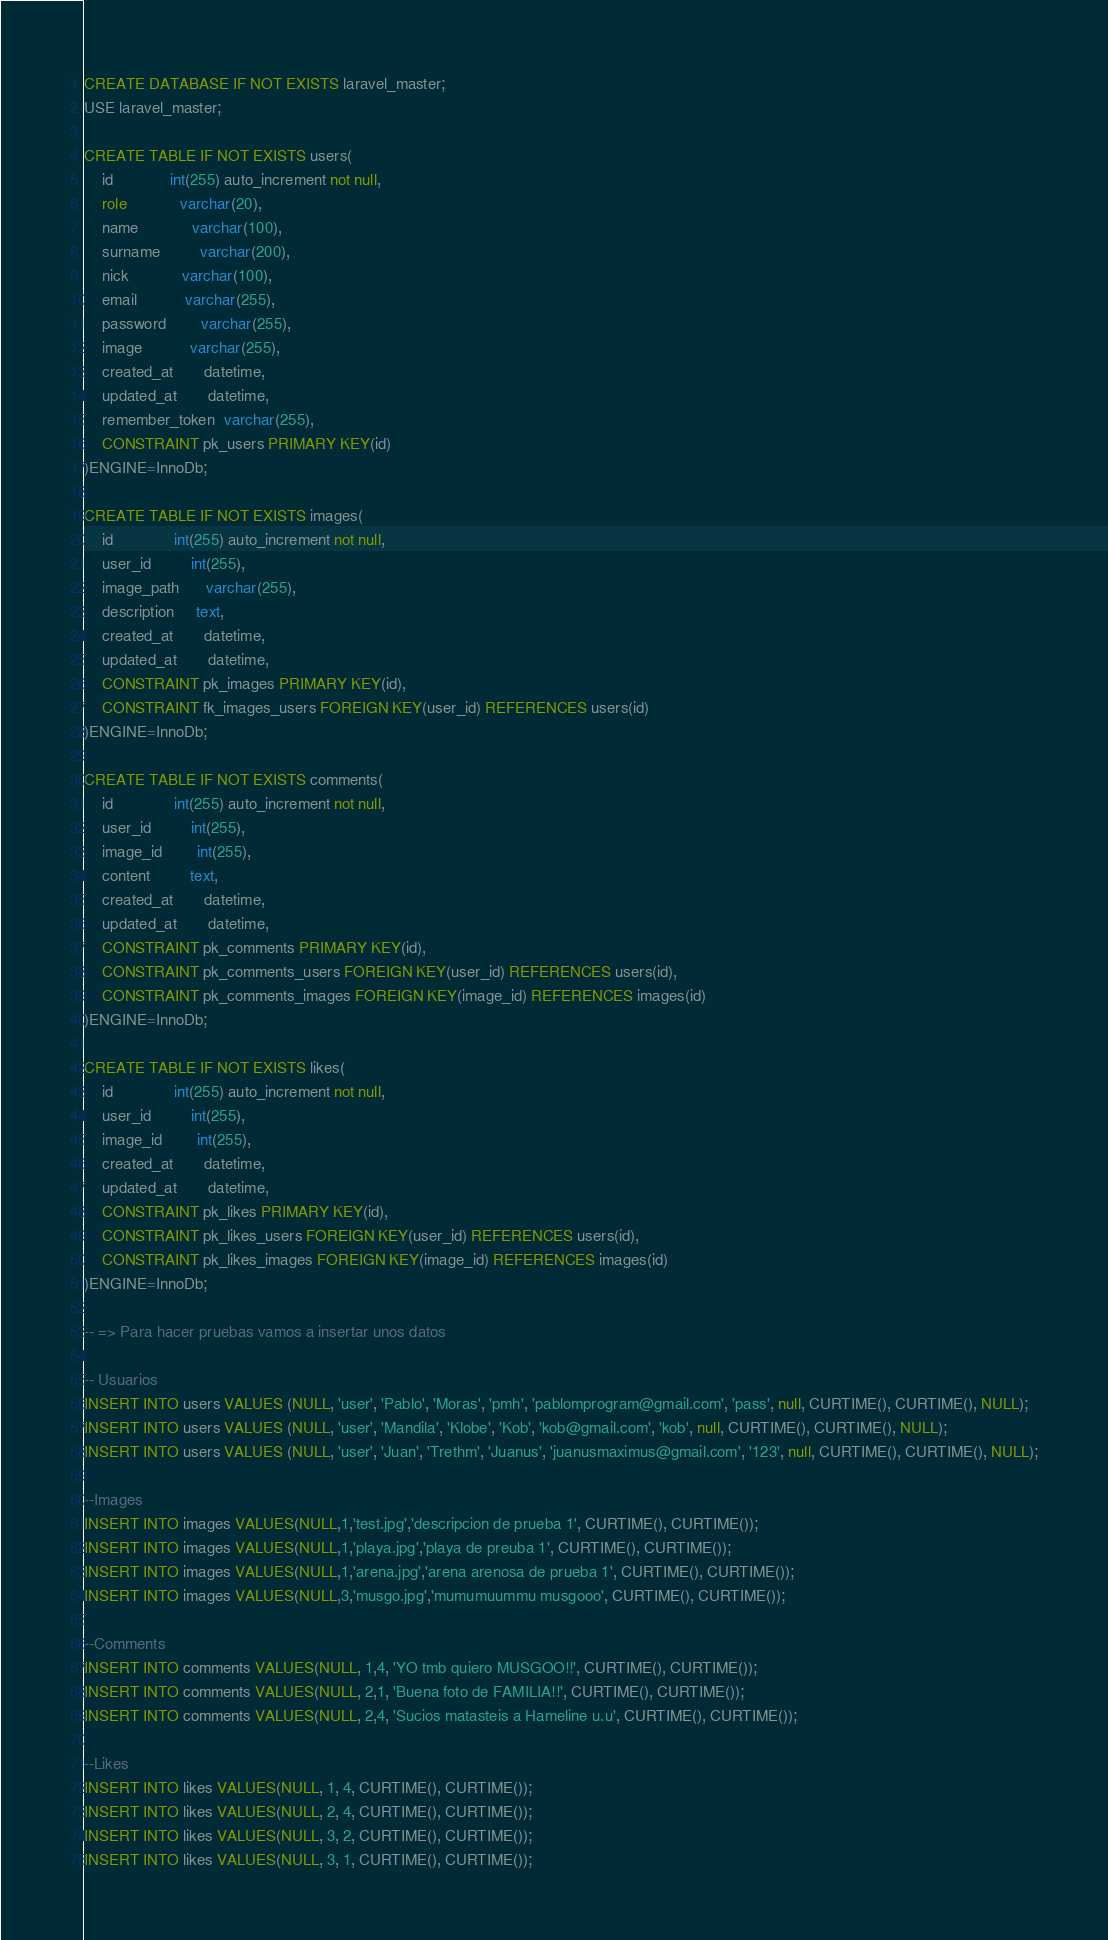Convert code to text. <code><loc_0><loc_0><loc_500><loc_500><_SQL_>CREATE DATABASE IF NOT EXISTS laravel_master;
USE laravel_master;

CREATE TABLE IF NOT EXISTS users(
    id             int(255) auto_increment not null,
    role            varchar(20),
    name            varchar(100),
    surname         varchar(200),
    nick            varchar(100),
    email           varchar(255),
    password        varchar(255),
    image           varchar(255),
    created_at       datetime,
    updated_at       datetime,
    remember_token  varchar(255),
    CONSTRAINT pk_users PRIMARY KEY(id)
)ENGINE=InnoDb;

CREATE TABLE IF NOT EXISTS images(
    id              int(255) auto_increment not null,
    user_id         int(255),
    image_path      varchar(255),
    description     text,
    created_at       datetime,
    updated_at       datetime,
    CONSTRAINT pk_images PRIMARY KEY(id),
    CONSTRAINT fk_images_users FOREIGN KEY(user_id) REFERENCES users(id)
)ENGINE=InnoDb;

CREATE TABLE IF NOT EXISTS comments(
    id              int(255) auto_increment not null,
    user_id         int(255),
    image_id        int(255),
    content         text,
    created_at       datetime,
    updated_at       datetime,
    CONSTRAINT pk_comments PRIMARY KEY(id),
    CONSTRAINT pk_comments_users FOREIGN KEY(user_id) REFERENCES users(id),
    CONSTRAINT pk_comments_images FOREIGN KEY(image_id) REFERENCES images(id)
)ENGINE=InnoDb;

CREATE TABLE IF NOT EXISTS likes(
    id              int(255) auto_increment not null,
    user_id         int(255),
    image_id        int(255),
    created_at       datetime,
    updated_at       datetime,
    CONSTRAINT pk_likes PRIMARY KEY(id),
    CONSTRAINT pk_likes_users FOREIGN KEY(user_id) REFERENCES users(id),
    CONSTRAINT pk_likes_images FOREIGN KEY(image_id) REFERENCES images(id)
)ENGINE=InnoDb;

-- => Para hacer pruebas vamos a insertar unos datos

-- Usuarios
INSERT INTO users VALUES (NULL, 'user', 'Pablo', 'Moras', 'pmh', 'pablomprogram@gmail.com', 'pass', null, CURTIME(), CURTIME(), NULL);
INSERT INTO users VALUES (NULL, 'user', 'Mandila', 'Klobe', 'Kob', 'kob@gmail.com', 'kob', null, CURTIME(), CURTIME(), NULL);
INSERT INTO users VALUES (NULL, 'user', 'Juan', 'Trethm', 'Juanus', 'juanusmaximus@gmail.com', '123', null, CURTIME(), CURTIME(), NULL);

--Images
INSERT INTO images VALUES(NULL,1,'test.jpg','descripcion de prueba 1', CURTIME(), CURTIME());
INSERT INTO images VALUES(NULL,1,'playa.jpg','playa de preuba 1', CURTIME(), CURTIME());
INSERT INTO images VALUES(NULL,1,'arena.jpg','arena arenosa de prueba 1', CURTIME(), CURTIME());
INSERT INTO images VALUES(NULL,3,'musgo.jpg','mumumuummu musgooo', CURTIME(), CURTIME());

--Comments
INSERT INTO comments VALUES(NULL, 1,4, 'YO tmb quiero MUSGOO!!', CURTIME(), CURTIME());
INSERT INTO comments VALUES(NULL, 2,1, 'Buena foto de FAMILIA!!', CURTIME(), CURTIME());
INSERT INTO comments VALUES(NULL, 2,4, 'Sucios matasteis a Hameline u.u', CURTIME(), CURTIME());

--Likes
INSERT INTO likes VALUES(NULL, 1, 4, CURTIME(), CURTIME());
INSERT INTO likes VALUES(NULL, 2, 4, CURTIME(), CURTIME());
INSERT INTO likes VALUES(NULL, 3, 2, CURTIME(), CURTIME());
INSERT INTO likes VALUES(NULL, 3, 1, CURTIME(), CURTIME());
</code> 